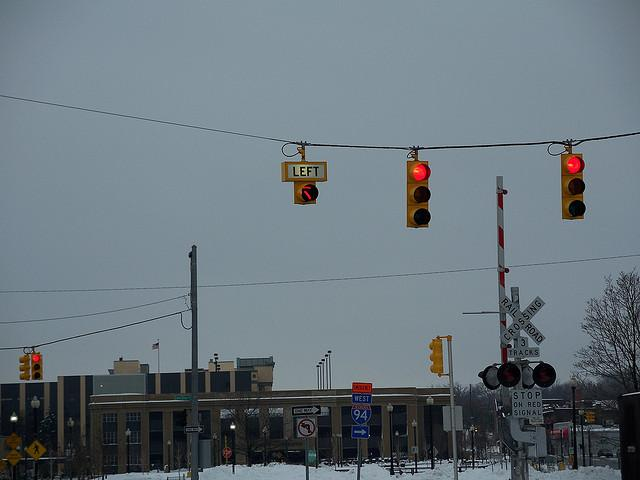What vehicle makes frequent crosses at this intersection?

Choices:
A) train
B) plane
C) motorcycle
D) trolley train 